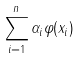<formula> <loc_0><loc_0><loc_500><loc_500>\sum _ { i = 1 } ^ { n } \alpha _ { i } \varphi ( x _ { i } )</formula> 